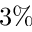<formula> <loc_0><loc_0><loc_500><loc_500>3 \%</formula> 